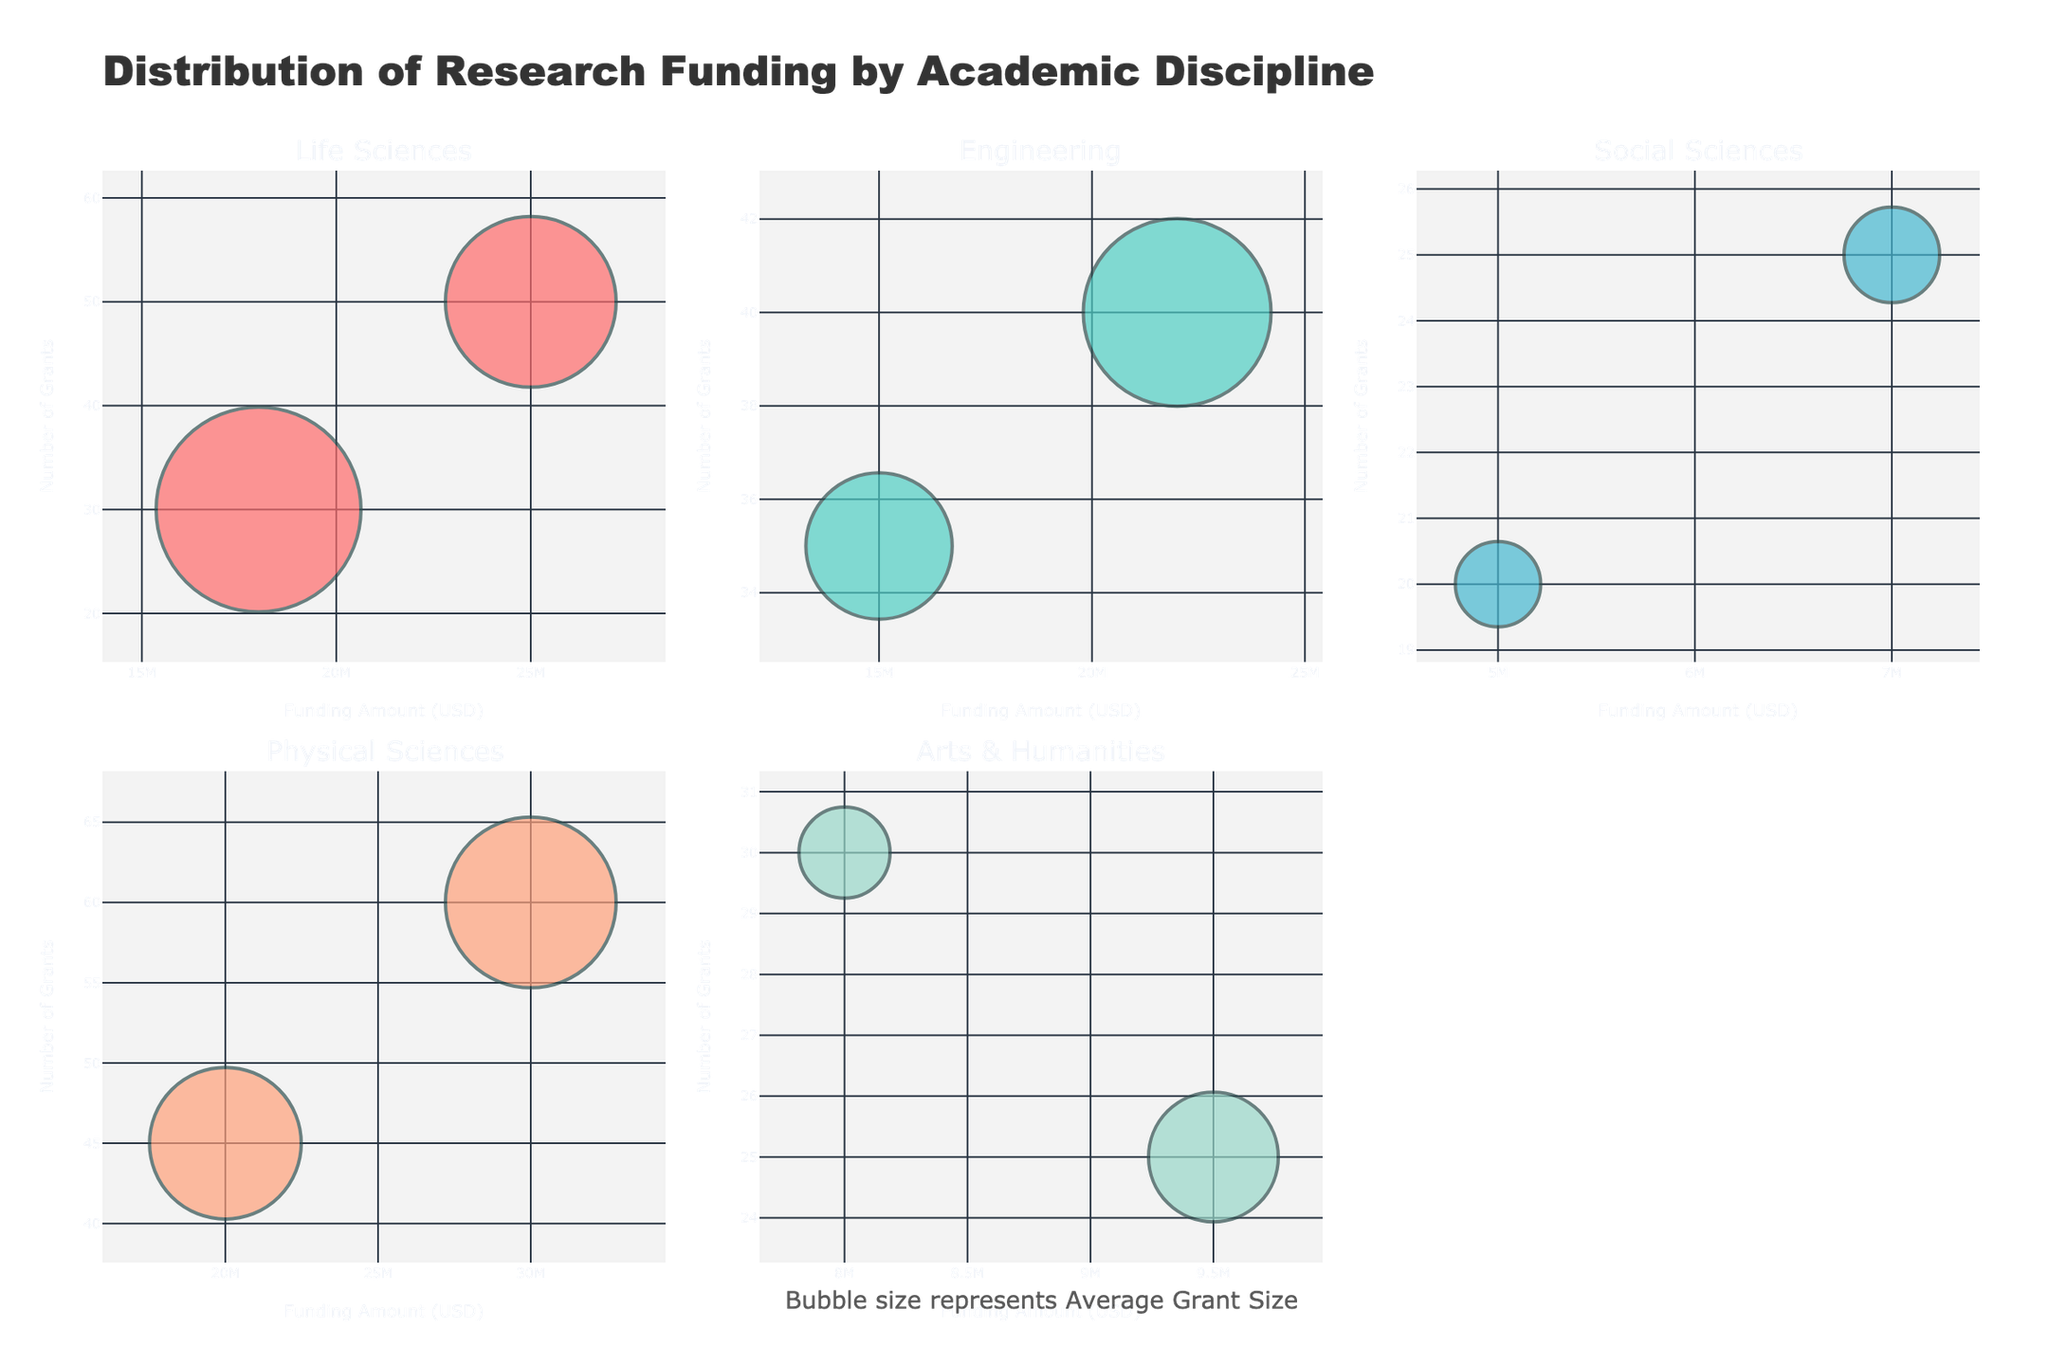How many academic disciplines are shown in the plot? Look at the subplot titles to count the number of different academic disciplines displayed in the figure.
Answer: 4 Which academic discipline has the largest funding amount for any grant type? Identify the subplot with the highest x-axis value, which represents the funding amount. The highest value is in the 'Physical Sciences' subplot.
Answer: Physical Sciences In the Life Sciences discipline, which grant type is associated with the highest number of grants? Look at the markers in the Life Sciences subplot and hover over them to see the 'Number of Grants' for each grant type. Identify the one with the highest y-axis value.
Answer: National Institutes of Health (NIH) Compare the average grant sizes for the National Endowment for the Humanities (NEH) in the Social Sciences and Arts & Humanities. Which is larger? Observe the Sizes of bubbles representing the NEH grant types in the Social Sciences and Arts & Humanities subplots. Identify the larger bubble.
Answer: Arts & Humanities For the National Science Foundation (NSF), which academic discipline has the highest number of grants? Locate the NSF markers in each subplot. Compare their y-axis positions to find the highest value.
Answer: Life Sciences What's the average number of grants given by the Department of Defense (DOD) and the National Aeronautics and Space Administration (NASA) in the Physical Sciences discipline? The Department of Defense (DOD) grants = 60, National Aeronautics and Space Administration (NASA) grants = 45, so (60+45)/2 = 52.5
Answer: 52.5 Which grant type in Engineering has the smallest average grant size, and what is the value? Hover over the bubbles in the Engineering subplot to identify the grant types with their average grant sizes. The smallest value is for NSF grants.
Answer: National Science Foundation (NSF), 428571 What is the total funding amount for grant types in the Arts & Humanities discipline? Sum the x-axis values for the grant types in the Arts & Humanities subplot: 8000000 + 9500000 = 17500000
Answer: 17500000 Between the Life Sciences and Social Sciences, which has a grant type with fewer grants but a larger average grant size? Compare the y-axis values and bubble sizes in the Life Sciences and Social Sciences subplots. Life Sciences has NIH with fewer grants but larger average grant size.
Answer: Life Sciences Is there a grant type in the figure that has both a high number of grants and a small average grant size? Identify it. Look for smaller bubbles (indicating smaller average grant sizes) that are higher up on the y-axis (indicating more grants). The NSF in Engineering fits this description.
Answer: National Science Foundation (NSF) in Engineering 